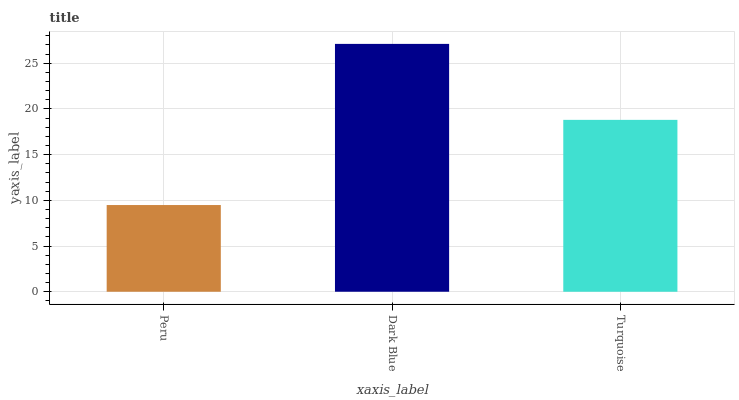Is Peru the minimum?
Answer yes or no. Yes. Is Dark Blue the maximum?
Answer yes or no. Yes. Is Turquoise the minimum?
Answer yes or no. No. Is Turquoise the maximum?
Answer yes or no. No. Is Dark Blue greater than Turquoise?
Answer yes or no. Yes. Is Turquoise less than Dark Blue?
Answer yes or no. Yes. Is Turquoise greater than Dark Blue?
Answer yes or no. No. Is Dark Blue less than Turquoise?
Answer yes or no. No. Is Turquoise the high median?
Answer yes or no. Yes. Is Turquoise the low median?
Answer yes or no. Yes. Is Peru the high median?
Answer yes or no. No. Is Peru the low median?
Answer yes or no. No. 